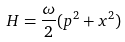Convert formula to latex. <formula><loc_0><loc_0><loc_500><loc_500>H = \frac { \omega } { 2 } ( p ^ { 2 } + x ^ { 2 } )</formula> 